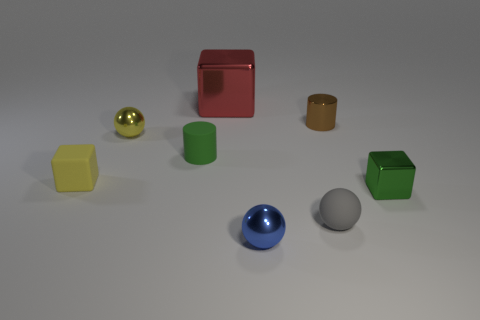Subtract all red blocks. How many blocks are left? 2 Add 1 shiny spheres. How many objects exist? 9 Subtract all green cubes. How many cubes are left? 2 Subtract all cylinders. How many objects are left? 6 Add 8 brown shiny objects. How many brown shiny objects are left? 9 Add 1 tiny gray metal objects. How many tiny gray metal objects exist? 1 Subtract 1 yellow balls. How many objects are left? 7 Subtract 1 balls. How many balls are left? 2 Subtract all red cubes. Subtract all blue spheres. How many cubes are left? 2 Subtract all red cylinders. How many brown blocks are left? 0 